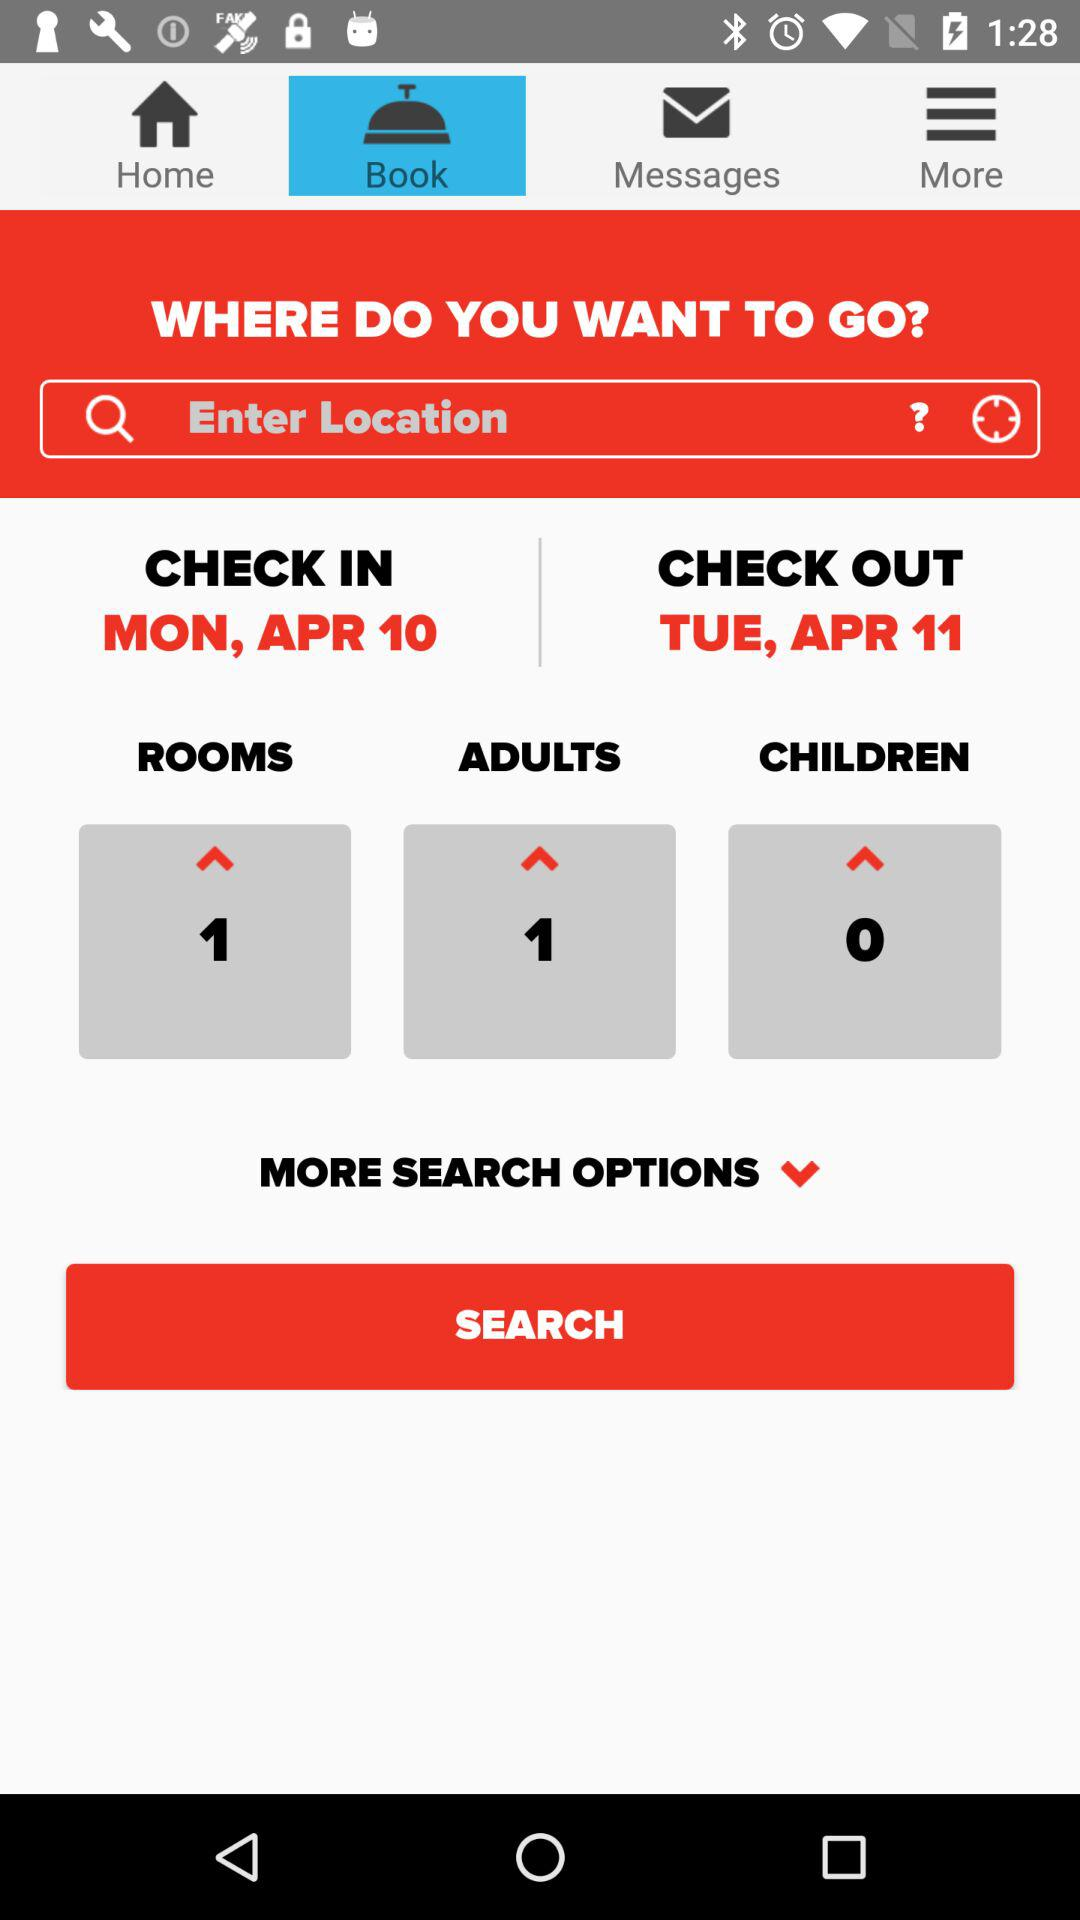What is the count of adults? The count of adults is 1. 